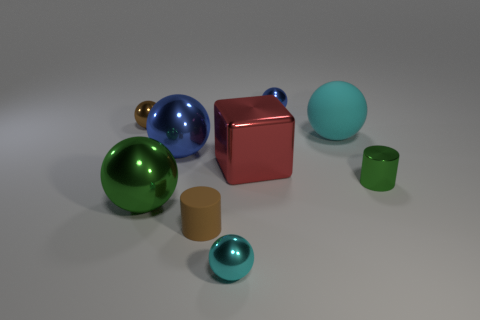There is a big sphere that is in front of the green thing that is to the right of the blue thing to the left of the tiny blue metallic thing; what is its material?
Make the answer very short. Metal. There is a blue object that is in front of the brown metal object; is it the same size as the large red metal block?
Your answer should be very brief. Yes. What is the material of the blue sphere on the left side of the red shiny cube?
Provide a succinct answer. Metal. Is the number of large blue objects greater than the number of blue metallic things?
Ensure brevity in your answer.  No. What number of things are either objects that are to the right of the small blue object or large brown rubber cylinders?
Your answer should be very brief. 2. There is a cyan thing left of the large red metallic block; what number of large objects are to the left of it?
Your answer should be very brief. 2. There is a blue metallic ball in front of the small sphere that is left of the blue metal ball that is in front of the small blue object; what size is it?
Your response must be concise. Large. There is a tiny ball to the right of the cyan metal thing; is it the same color as the matte sphere?
Ensure brevity in your answer.  No. There is another green thing that is the same shape as the tiny matte object; what size is it?
Ensure brevity in your answer.  Small. What number of things are either balls that are in front of the brown rubber thing or big things that are in front of the large shiny cube?
Offer a terse response. 2. 